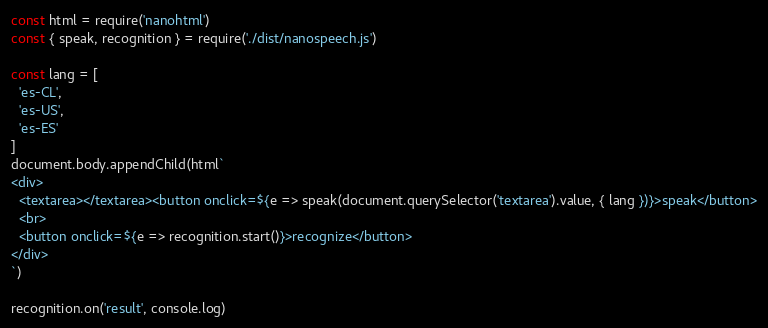Convert code to text. <code><loc_0><loc_0><loc_500><loc_500><_JavaScript_>const html = require('nanohtml')
const { speak, recognition } = require('./dist/nanospeech.js')

const lang = [
  'es-CL',
  'es-US',
  'es-ES'
]
document.body.appendChild(html`
<div>
  <textarea></textarea><button onclick=${e => speak(document.querySelector('textarea').value, { lang })}>speak</button>
  <br>
  <button onclick=${e => recognition.start()}>recognize</button>
</div>
`)

recognition.on('result', console.log)
</code> 